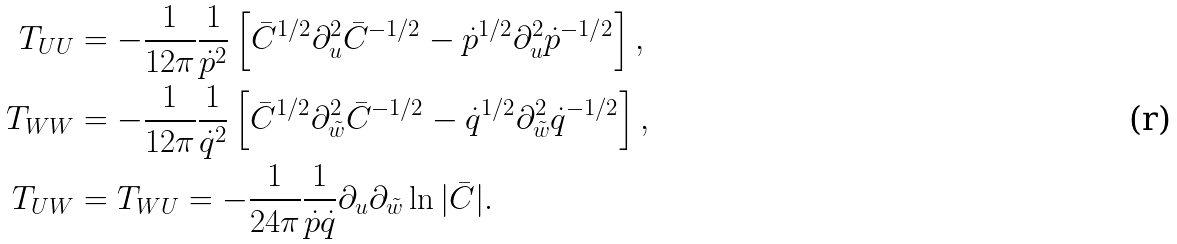Convert formula to latex. <formula><loc_0><loc_0><loc_500><loc_500>T _ { U U } & = - \frac { 1 } { 1 2 \pi } \frac { 1 } { \dot { p } ^ { 2 } } \left [ \bar { C } ^ { 1 / 2 } \partial _ { u } ^ { 2 } \bar { C } ^ { - 1 / 2 } - \dot { p } ^ { 1 / 2 } \partial _ { u } ^ { 2 } \dot { p } ^ { - 1 / 2 } \right ] , \\ T _ { W W } & = - \frac { 1 } { 1 2 \pi } \frac { 1 } { \dot { q } ^ { 2 } } \left [ \bar { C } ^ { 1 / 2 } \partial _ { \tilde { w } } ^ { 2 } \bar { C } ^ { - 1 / 2 } - \dot { q } ^ { 1 / 2 } \partial _ { \tilde { w } } ^ { 2 } \dot { q } ^ { - 1 / 2 } \right ] , \\ T _ { U W } & = T _ { W U } = - \frac { 1 } { 2 4 \pi } \frac { 1 } { \dot { p } \dot { q } } \partial _ { u } \partial _ { \tilde { w } } \ln | \bar { C } | .</formula> 